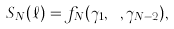<formula> <loc_0><loc_0><loc_500><loc_500>S _ { N } ( \ell ) = f _ { N } ( \gamma _ { 1 } , \cdots , \gamma _ { N - 2 } ) ,</formula> 